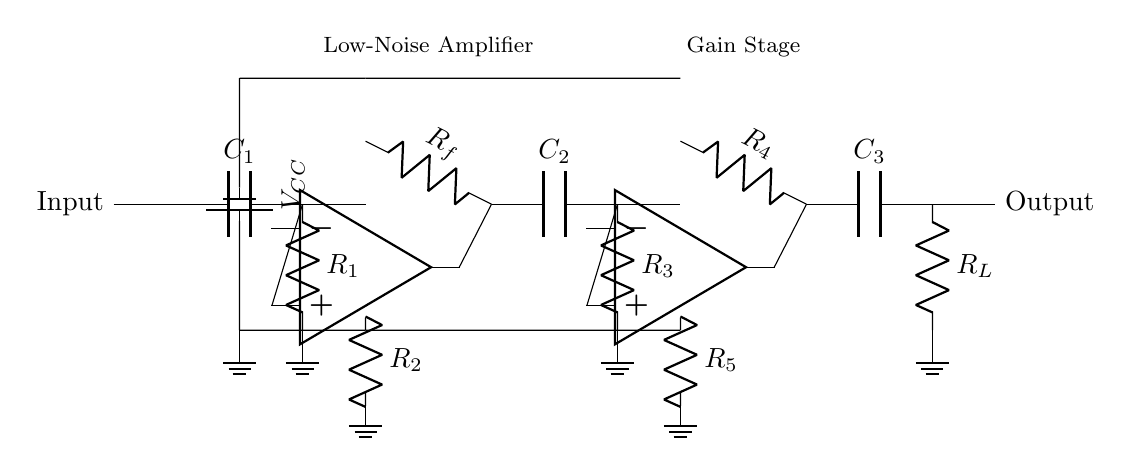What is the type of the main components used in this circuit? The circuits consist mainly of operational amplifiers, resistors, and capacitors, which are essential for signal amplification and filtering.
Answer: operational amplifiers, resistors, capacitors How many resistors are present in the circuit? By counting the resistors labeled as R1, R2, R3, R4, and R5, we find that there are five resistors in total.
Answer: five What is the function of capacitor C1? Capacitor C1 is typically used for coupling the input signal and blocking any DC offset, ensuring only the AC signals are processed further.
Answer: coupling What does the gain stage in this circuit achieve? The gain stage is responsible for increasing the amplitude of the input audio signal, allowing for clearer recordings.
Answer: increasing amplitude What is the purpose of the noise reduction filter in the amplifier? The noise reduction filter minimizes any unwanted noise that may affect the clarity of audio recordings, enhancing the overall quality.
Answer: minimizing unwanted noise How many stages are present in this amplifier circuit? The circuit has two amplifier stages indicated in the diagram, which process the signal sequentially to improve performance.
Answer: two 